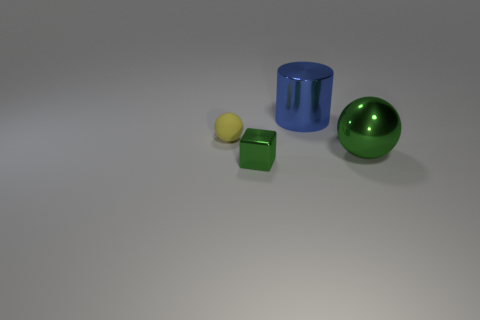Add 4 small purple cylinders. How many objects exist? 8 Subtract all cylinders. How many objects are left? 3 Add 4 matte objects. How many matte objects exist? 5 Subtract 0 red cylinders. How many objects are left? 4 Subtract all big purple rubber blocks. Subtract all large metallic things. How many objects are left? 2 Add 4 metal spheres. How many metal spheres are left? 5 